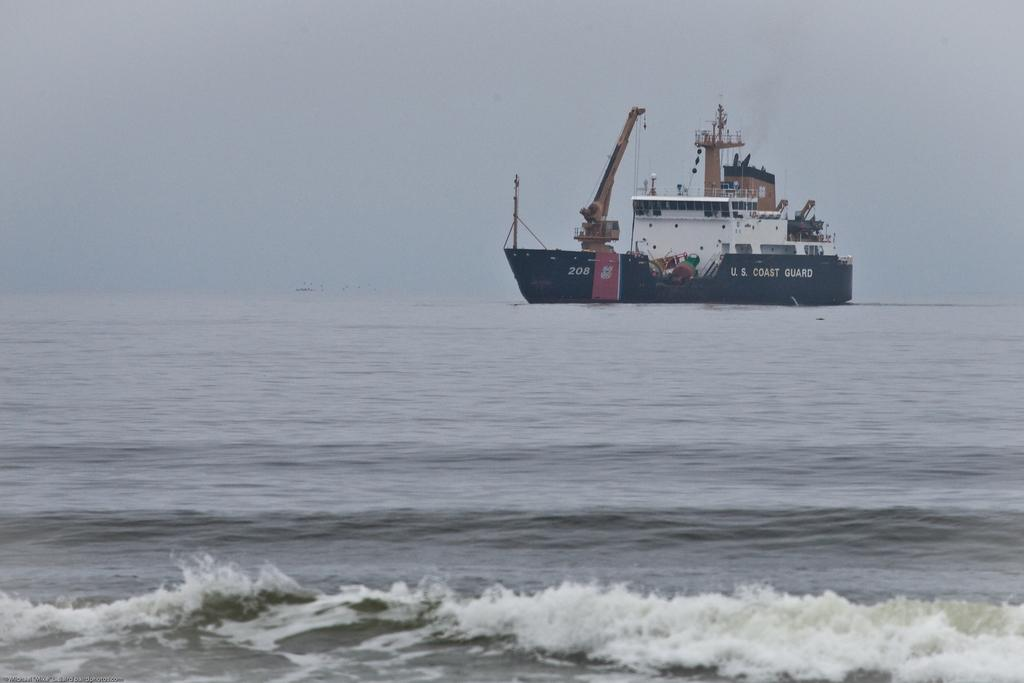What is the main subject of the image? The main subject of the image is a ship. What colors are used to depict the ship? The ship is in white and black colors. Where is the ship located in the image? The ship is in water. What is visible at the top of the image? The sky is visible at the top of the image. How many silver tickets can be seen on the ship in the image? There is no mention of silver tickets in the image, and therefore no such items can be observed. Can you describe the tramp that is on the ship in the image? There is no tramp present on the ship in the image. 